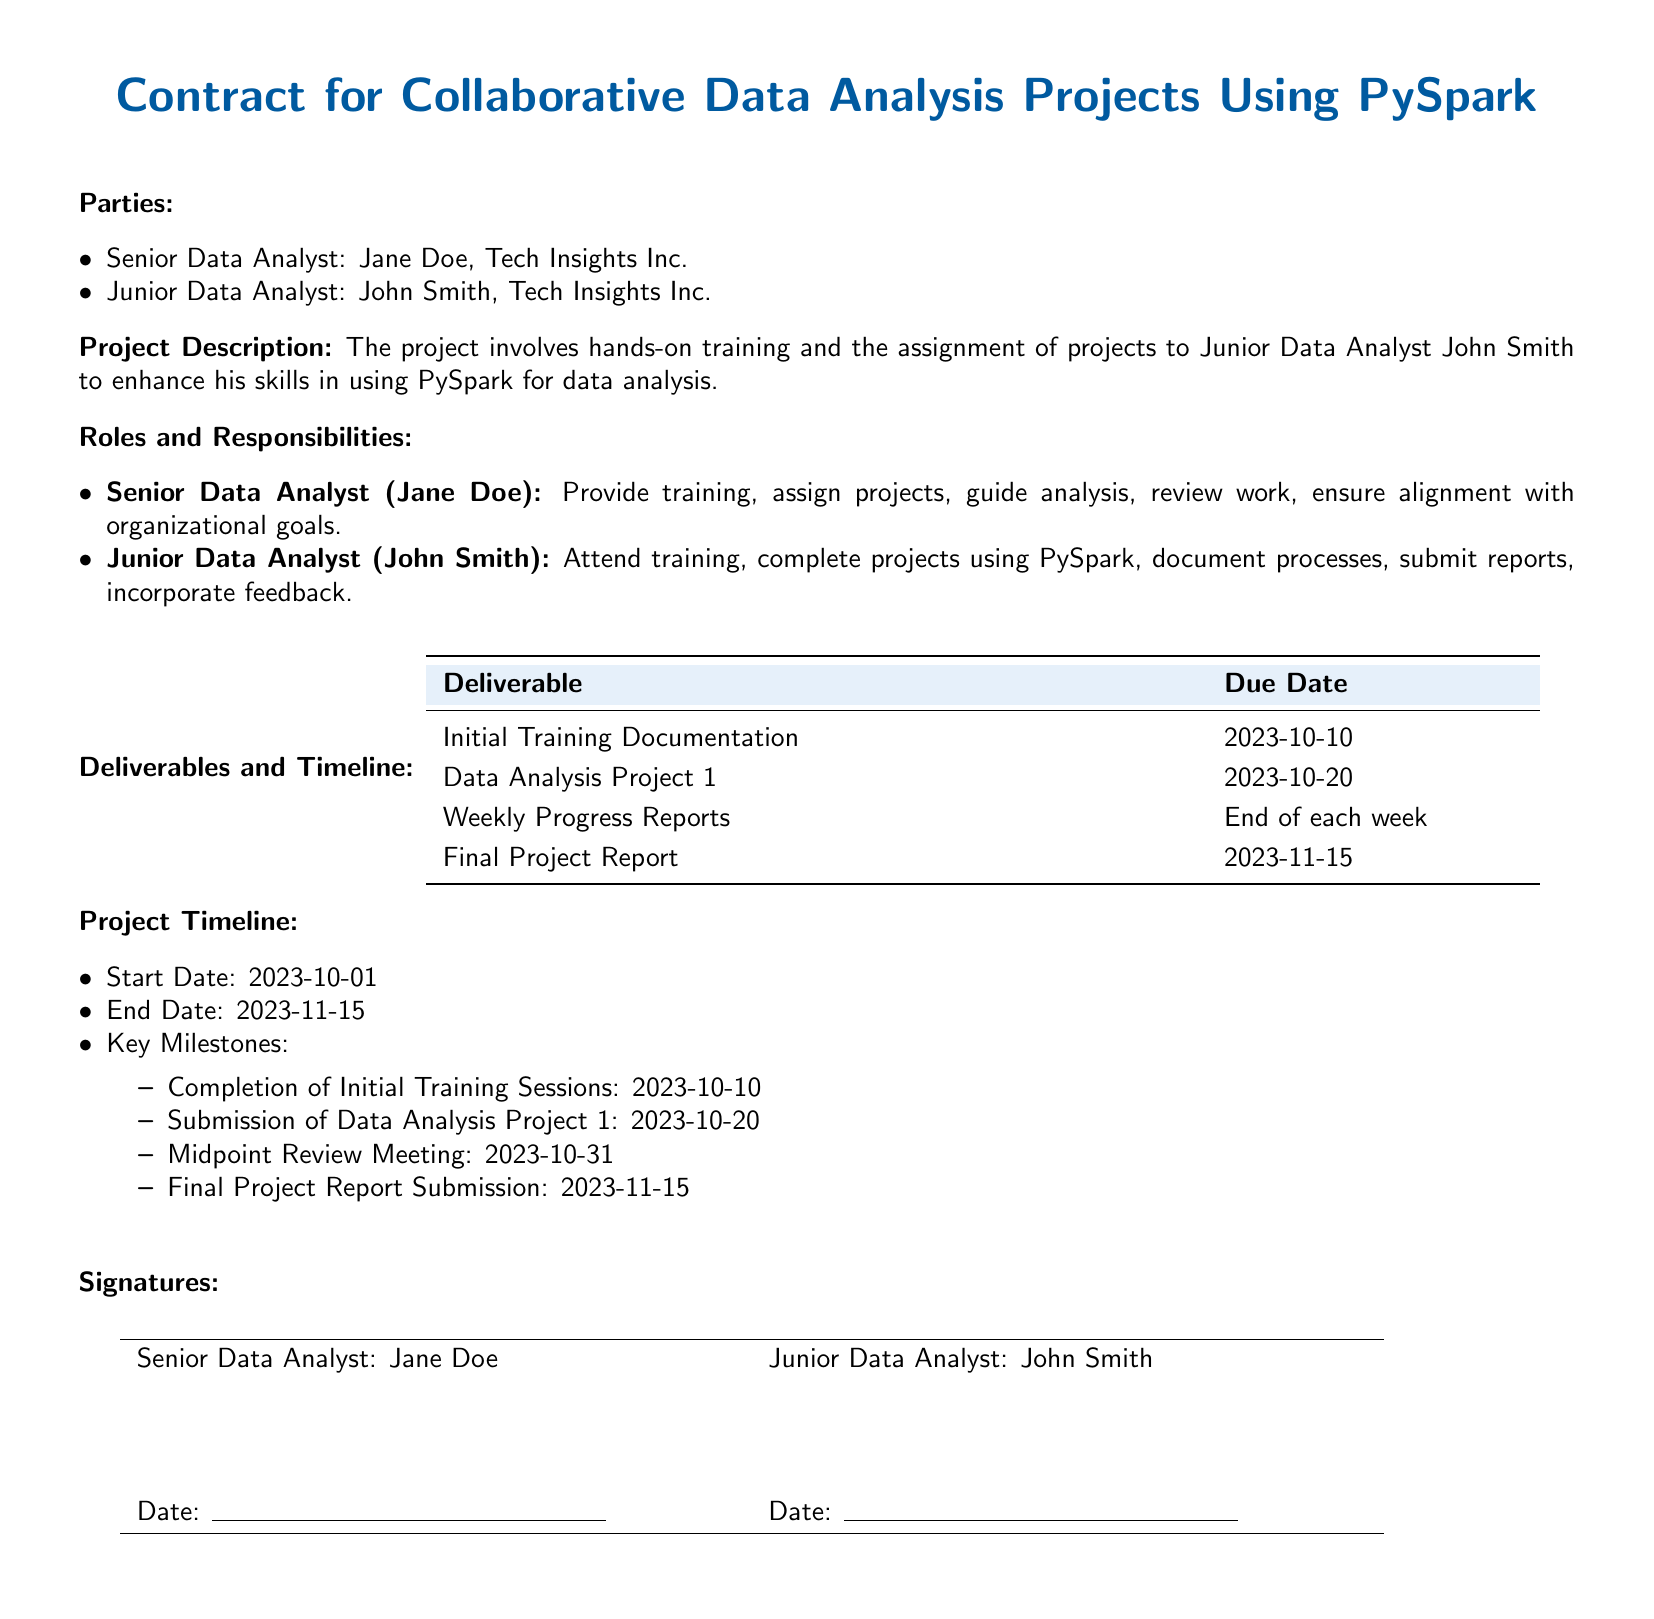What is the title of the document? The title is prominently displayed at the beginning of the document, indicating the subject of the contract.
Answer: Contract for Collaborative Data Analysis Projects Using PySpark Who is the Senior Data Analyst? The contract identifies the Senior Data Analyst by name under the Parties section.
Answer: Jane Doe What is the due date for Data Analysis Project 1? The contract specifies the due date for this deliverable in the Deliverables and Timeline table.
Answer: 2023-10-20 What is the start date of the project? The start date is mentioned in the Project Timeline section.
Answer: 2023-10-01 What are Junior Data Analyst John Smith's primary responsibilities? The roles and responsibilities section outlines specific tasks for John Smith.
Answer: Attend training, complete projects using PySpark, document processes, submit reports, incorporate feedback When is the midpoint review meeting scheduled? This date is listed under the Project Timeline section.
Answer: 2023-10-31 What is the final project report submission date? The specific date for this deliverable is provided in the Deliverables and Timeline table.
Answer: 2023-11-15 How many key milestones are listed in the project timeline? This can be inferred from the Project Timeline section where the milestones are enumerated.
Answer: Four What section outlines the parties involved in the contract? The parties involved are detailed in a specific section of the document.
Answer: Parties 